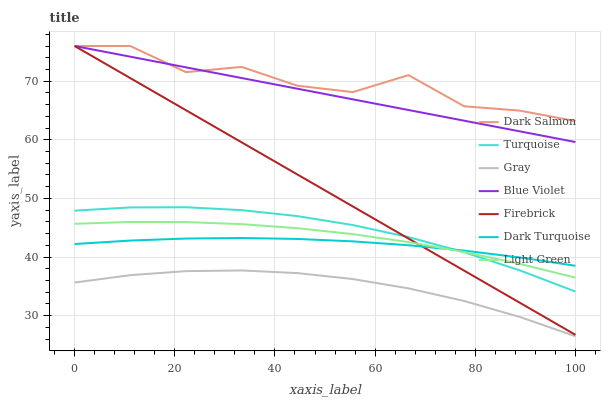Does Gray have the minimum area under the curve?
Answer yes or no. Yes. Does Dark Salmon have the maximum area under the curve?
Answer yes or no. Yes. Does Turquoise have the minimum area under the curve?
Answer yes or no. No. Does Turquoise have the maximum area under the curve?
Answer yes or no. No. Is Firebrick the smoothest?
Answer yes or no. Yes. Is Dark Salmon the roughest?
Answer yes or no. Yes. Is Turquoise the smoothest?
Answer yes or no. No. Is Turquoise the roughest?
Answer yes or no. No. Does Turquoise have the lowest value?
Answer yes or no. No. Does Blue Violet have the highest value?
Answer yes or no. Yes. Does Turquoise have the highest value?
Answer yes or no. No. Is Gray less than Firebrick?
Answer yes or no. Yes. Is Blue Violet greater than Turquoise?
Answer yes or no. Yes. Does Turquoise intersect Light Green?
Answer yes or no. Yes. Is Turquoise less than Light Green?
Answer yes or no. No. Is Turquoise greater than Light Green?
Answer yes or no. No. Does Gray intersect Firebrick?
Answer yes or no. No. 